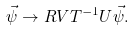<formula> <loc_0><loc_0><loc_500><loc_500>\vec { \psi } \rightarrow { R } { V } { T } ^ { - 1 } { U } \vec { \psi } .</formula> 